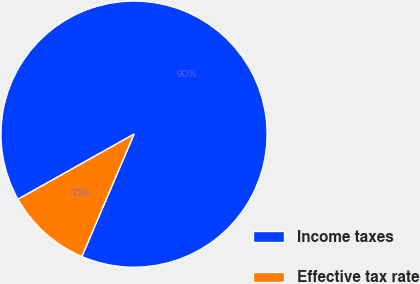Convert chart. <chart><loc_0><loc_0><loc_500><loc_500><pie_chart><fcel>Income taxes<fcel>Effective tax rate<nl><fcel>89.55%<fcel>10.45%<nl></chart> 